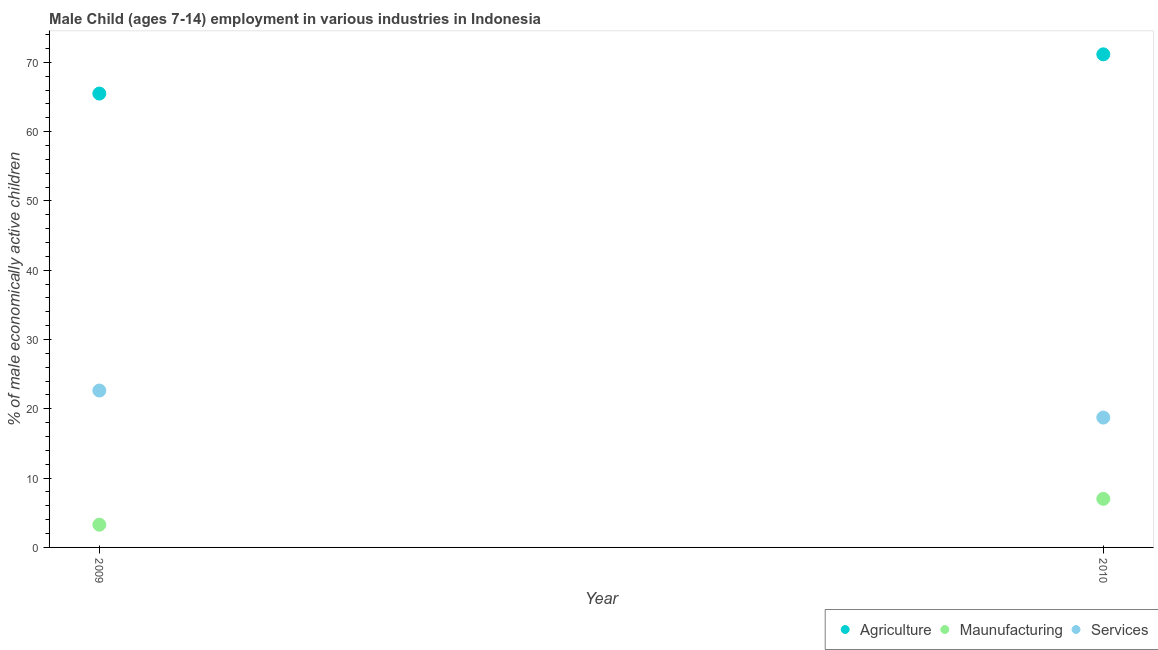Is the number of dotlines equal to the number of legend labels?
Your answer should be compact. Yes. What is the percentage of economically active children in manufacturing in 2009?
Make the answer very short. 3.28. Across all years, what is the maximum percentage of economically active children in services?
Give a very brief answer. 22.64. Across all years, what is the minimum percentage of economically active children in agriculture?
Make the answer very short. 65.5. In which year was the percentage of economically active children in agriculture maximum?
Provide a succinct answer. 2010. What is the total percentage of economically active children in manufacturing in the graph?
Provide a short and direct response. 10.29. What is the difference between the percentage of economically active children in agriculture in 2009 and that in 2010?
Your response must be concise. -5.66. What is the difference between the percentage of economically active children in agriculture in 2010 and the percentage of economically active children in manufacturing in 2009?
Give a very brief answer. 67.88. What is the average percentage of economically active children in services per year?
Ensure brevity in your answer.  20.69. In the year 2009, what is the difference between the percentage of economically active children in services and percentage of economically active children in agriculture?
Make the answer very short. -42.86. What is the ratio of the percentage of economically active children in services in 2009 to that in 2010?
Provide a short and direct response. 1.21. Does the percentage of economically active children in agriculture monotonically increase over the years?
Give a very brief answer. Yes. Is the percentage of economically active children in services strictly greater than the percentage of economically active children in agriculture over the years?
Give a very brief answer. No. How many dotlines are there?
Make the answer very short. 3. How many years are there in the graph?
Ensure brevity in your answer.  2. What is the difference between two consecutive major ticks on the Y-axis?
Keep it short and to the point. 10. Does the graph contain any zero values?
Offer a terse response. No. What is the title of the graph?
Your answer should be very brief. Male Child (ages 7-14) employment in various industries in Indonesia. Does "Manufactures" appear as one of the legend labels in the graph?
Offer a terse response. No. What is the label or title of the Y-axis?
Provide a succinct answer. % of male economically active children. What is the % of male economically active children of Agriculture in 2009?
Give a very brief answer. 65.5. What is the % of male economically active children of Maunufacturing in 2009?
Provide a succinct answer. 3.28. What is the % of male economically active children in Services in 2009?
Provide a short and direct response. 22.64. What is the % of male economically active children in Agriculture in 2010?
Your answer should be very brief. 71.16. What is the % of male economically active children in Maunufacturing in 2010?
Offer a terse response. 7.01. What is the % of male economically active children of Services in 2010?
Ensure brevity in your answer.  18.74. Across all years, what is the maximum % of male economically active children in Agriculture?
Ensure brevity in your answer.  71.16. Across all years, what is the maximum % of male economically active children of Maunufacturing?
Provide a succinct answer. 7.01. Across all years, what is the maximum % of male economically active children in Services?
Offer a very short reply. 22.64. Across all years, what is the minimum % of male economically active children of Agriculture?
Offer a very short reply. 65.5. Across all years, what is the minimum % of male economically active children of Maunufacturing?
Give a very brief answer. 3.28. Across all years, what is the minimum % of male economically active children of Services?
Provide a succinct answer. 18.74. What is the total % of male economically active children in Agriculture in the graph?
Your response must be concise. 136.66. What is the total % of male economically active children in Maunufacturing in the graph?
Provide a short and direct response. 10.29. What is the total % of male economically active children of Services in the graph?
Your response must be concise. 41.38. What is the difference between the % of male economically active children of Agriculture in 2009 and that in 2010?
Your answer should be compact. -5.66. What is the difference between the % of male economically active children in Maunufacturing in 2009 and that in 2010?
Keep it short and to the point. -3.73. What is the difference between the % of male economically active children in Agriculture in 2009 and the % of male economically active children in Maunufacturing in 2010?
Keep it short and to the point. 58.49. What is the difference between the % of male economically active children in Agriculture in 2009 and the % of male economically active children in Services in 2010?
Your answer should be very brief. 46.76. What is the difference between the % of male economically active children of Maunufacturing in 2009 and the % of male economically active children of Services in 2010?
Your answer should be very brief. -15.46. What is the average % of male economically active children of Agriculture per year?
Offer a very short reply. 68.33. What is the average % of male economically active children in Maunufacturing per year?
Your response must be concise. 5.14. What is the average % of male economically active children of Services per year?
Offer a very short reply. 20.69. In the year 2009, what is the difference between the % of male economically active children of Agriculture and % of male economically active children of Maunufacturing?
Give a very brief answer. 62.22. In the year 2009, what is the difference between the % of male economically active children of Agriculture and % of male economically active children of Services?
Provide a short and direct response. 42.86. In the year 2009, what is the difference between the % of male economically active children of Maunufacturing and % of male economically active children of Services?
Offer a terse response. -19.36. In the year 2010, what is the difference between the % of male economically active children of Agriculture and % of male economically active children of Maunufacturing?
Your response must be concise. 64.15. In the year 2010, what is the difference between the % of male economically active children of Agriculture and % of male economically active children of Services?
Offer a very short reply. 52.42. In the year 2010, what is the difference between the % of male economically active children of Maunufacturing and % of male economically active children of Services?
Make the answer very short. -11.73. What is the ratio of the % of male economically active children of Agriculture in 2009 to that in 2010?
Your response must be concise. 0.92. What is the ratio of the % of male economically active children of Maunufacturing in 2009 to that in 2010?
Your answer should be compact. 0.47. What is the ratio of the % of male economically active children in Services in 2009 to that in 2010?
Your answer should be compact. 1.21. What is the difference between the highest and the second highest % of male economically active children of Agriculture?
Provide a succinct answer. 5.66. What is the difference between the highest and the second highest % of male economically active children in Maunufacturing?
Provide a succinct answer. 3.73. What is the difference between the highest and the lowest % of male economically active children in Agriculture?
Your answer should be very brief. 5.66. What is the difference between the highest and the lowest % of male economically active children in Maunufacturing?
Keep it short and to the point. 3.73. What is the difference between the highest and the lowest % of male economically active children in Services?
Make the answer very short. 3.9. 